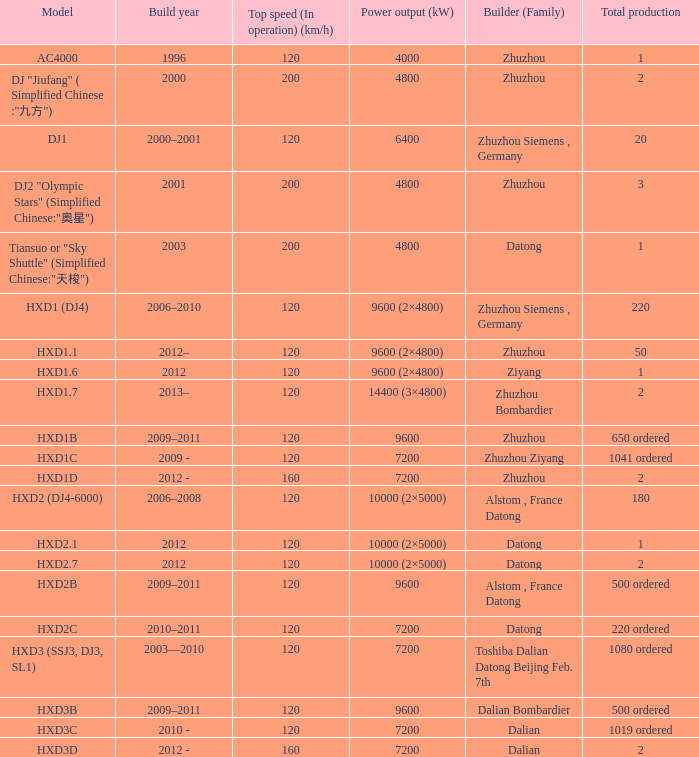What is the power generation (kw) of model hxd3d? 7200.0. 